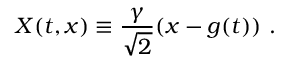Convert formula to latex. <formula><loc_0><loc_0><loc_500><loc_500>X ( t , x ) \equiv \frac { \gamma } { \sqrt { 2 } } ( x - g ( t ) ) \ .</formula> 